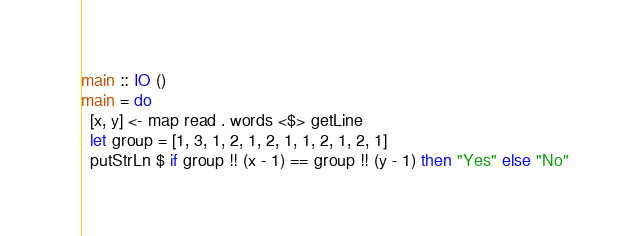Convert code to text. <code><loc_0><loc_0><loc_500><loc_500><_Haskell_>main :: IO ()
main = do
  [x, y] <- map read . words <$> getLine
  let group = [1, 3, 1, 2, 1, 2, 1, 1, 2, 1, 2, 1]
  putStrLn $ if group !! (x - 1) == group !! (y - 1) then "Yes" else "No"</code> 